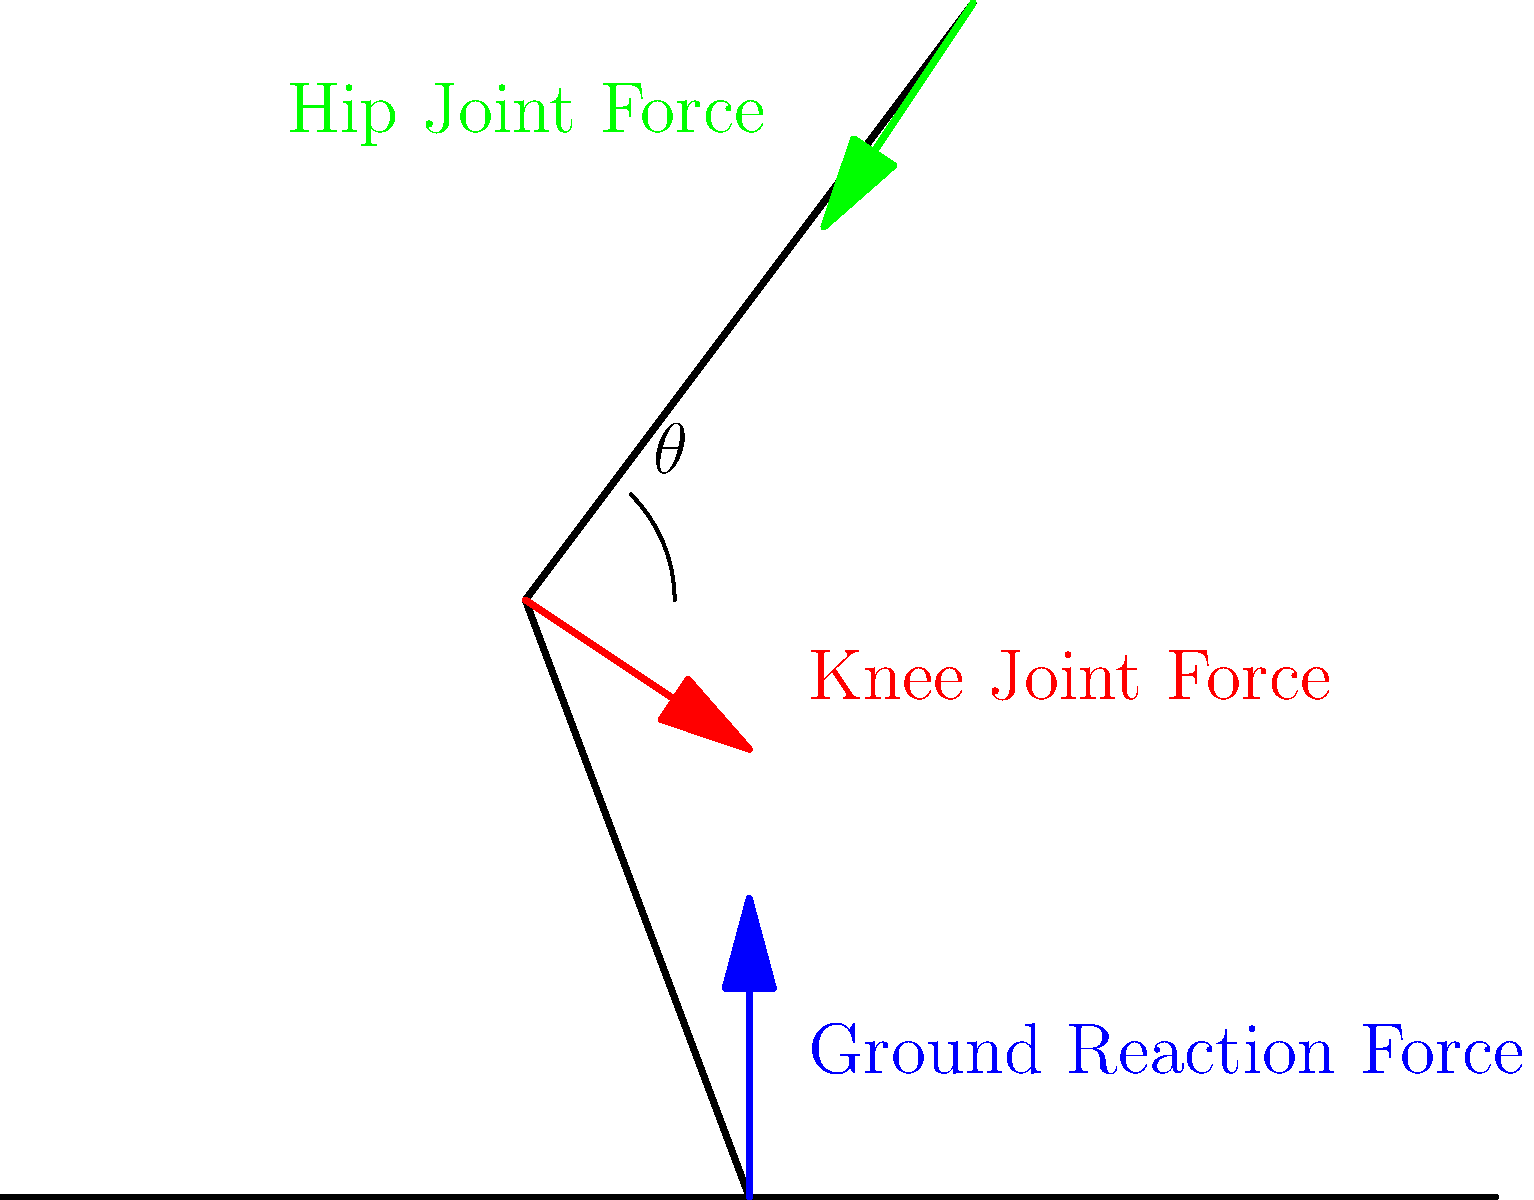Analyze the biomechanical illustration of a sprinter's stride. If the ground reaction force is 2000N, the knee angle ($\theta$) is 45°, and the hip joint force is 1500N, calculate the approximate magnitude of the knee joint force. Assume the leg segments are of equal length and the forces are in equilibrium. To solve this problem, we'll use the principle of force equilibrium and basic trigonometry. Let's break it down step-by-step:

1) First, we need to consider the forces acting on the lower leg segment:
   - Ground Reaction Force (GRF): 2000N upward
   - Knee Joint Force (KJF): Unknown, acting at 45° to the leg segment
   - Weight of the lower leg: We'll neglect this for simplification

2) For equilibrium, the vertical components of these forces must sum to zero:
   $GRF - KJF \cdot \sin(45°) = 0$

3) We know that $\sin(45°) = \frac{\sqrt{2}}{2}$, so we can rewrite the equation:
   $2000 - KJF \cdot \frac{\sqrt{2}}{2} = 0$

4) Solving for KJF:
   $KJF \cdot \frac{\sqrt{2}}{2} = 2000$
   $KJF = 2000 \cdot \frac{2}{\sqrt{2}} = 2000 \cdot \sqrt{2} \approx 2828N$

5) We can verify this by considering the horizontal component:
   $KJF \cdot \cos(45°) = 2828 \cdot \frac{\sqrt{2}}{2} = 2000N$

This horizontal force would be balanced by the hip joint force and the forward acceleration of the sprinter.

Note: This is a simplified model. In reality, muscle forces and dynamics would make the analysis more complex.
Answer: Approximately 2828N 